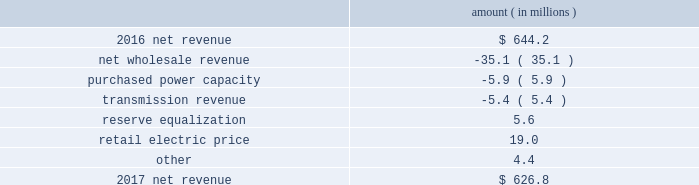Entergy texas , inc .
And subsidiaries management 2019s financial discussion and analysis results of operations net income 2017 compared to 2016 net income decreased $ 31.4 million primarily due to lower net revenue , higher depreciation and amortization expenses , higher other operation and maintenance expenses , and higher taxes other than income taxes .
2016 compared to 2015 net income increased $ 37.9 million primarily due to lower other operation and maintenance expenses , the asset write-off of its receivable associated with the spindletop gas storage facility in 2015 , and higher net revenue .
Net revenue 2017 compared to 2016 net revenue consists of operating revenues net of : 1 ) fuel , fuel-related expenses , and gas purchased for resale , 2 ) purchased power expenses , and 3 ) other regulatory charges .
Following is an analysis of the change in net revenue comparing 2017 to 2016 .
Amount ( in millions ) .
The net wholesale revenue variance is primarily due to lower net capacity revenues resulting from the termination of the purchased power agreements between entergy louisiana and entergy texas in august 2016 .
The purchased power capacity variance is primarily due to increased expenses due to capacity cost changes for ongoing purchased power capacity contracts .
The transmission revenue variance is primarily due to a decrease in the amount of transmission revenues allocated by miso .
The reserve equalization variance is due to the absence of reserve equalization expenses in 2017 as a result of entergy texas 2019s exit from the system agreement in august 2016 .
See note 2 to the financial statements for a discussion of the system agreement. .
Based on analysis of the change in net revenue what was the percentage change in the net revenue from 2016 to 2017? 
Computations: ((626.8 - 644.2) / 644.2)
Answer: -0.02701. 